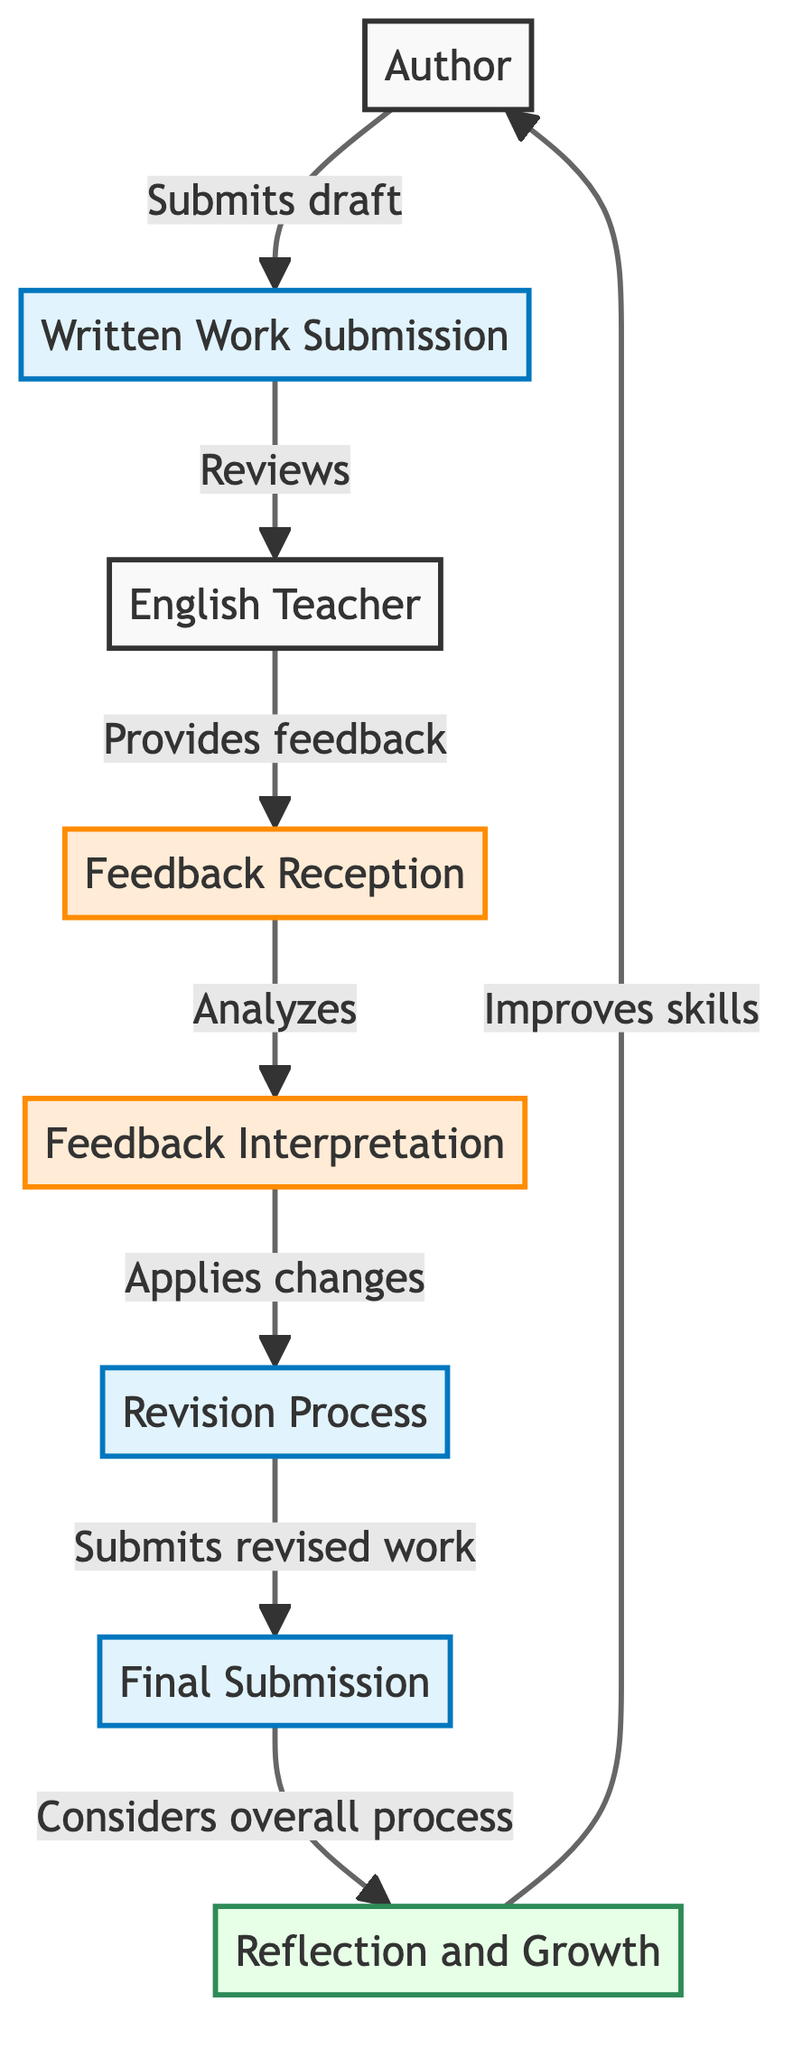What is the first step in the process? The diagram starts with the Author, who is the initial point of the process. The first step indicates that the Author engages in creating content.
Answer: Author How many main nodes are there in the diagram? By counting the nodes, we have a total of 8 different nodes representing various stages in the feedback loop.
Answer: 8 Which node provides feedback? The English Teacher node is the one that provides feedback after reviewing the written work submitted by the Author.
Answer: English Teacher What action follows the Feedback Reception node? After receiving the feedback, the next step is the Feedback Interpretation, where the Author analyzes the comments and suggestions provided by the English Teacher.
Answer: Feedback Interpretation In which step does the Author consider overall process changes? The Author considers the overall process after submitting the revised work, during the Reflection and Growth step.
Answer: Reflection and Growth What is the relationship between Revision Process and Final Submission? After the Revision Process, the next step is the Final Submission, indicating that the Author submits the revised draft for further assessment.
Answer: Submits revised work Which node indicates improvement in writing skills? The Reflection and Growth node indicates the process where the Author reflects on the feedback received to enhance their writing skills.
Answer: Reflection and Growth What does the arrow from Revised Work Submission to Final Submission represent? The arrow indicates the flow of the process, showing that the Author submits their revised work for further assessment.
Answer: Submits revised work What is the main focus of the Feedback Interpretation step? The main focus of the Feedback Interpretation step is to analyze and understand the feedback received from the English Teacher.
Answer: Analyzing and understanding feedback 